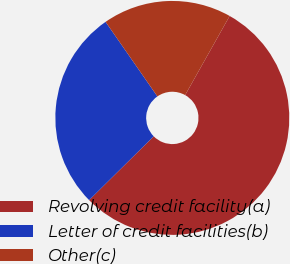Convert chart to OTSL. <chart><loc_0><loc_0><loc_500><loc_500><pie_chart><fcel>Revolving credit facility(a)<fcel>Letter of credit facilities(b)<fcel>Other(c)<nl><fcel>54.44%<fcel>27.74%<fcel>17.82%<nl></chart> 